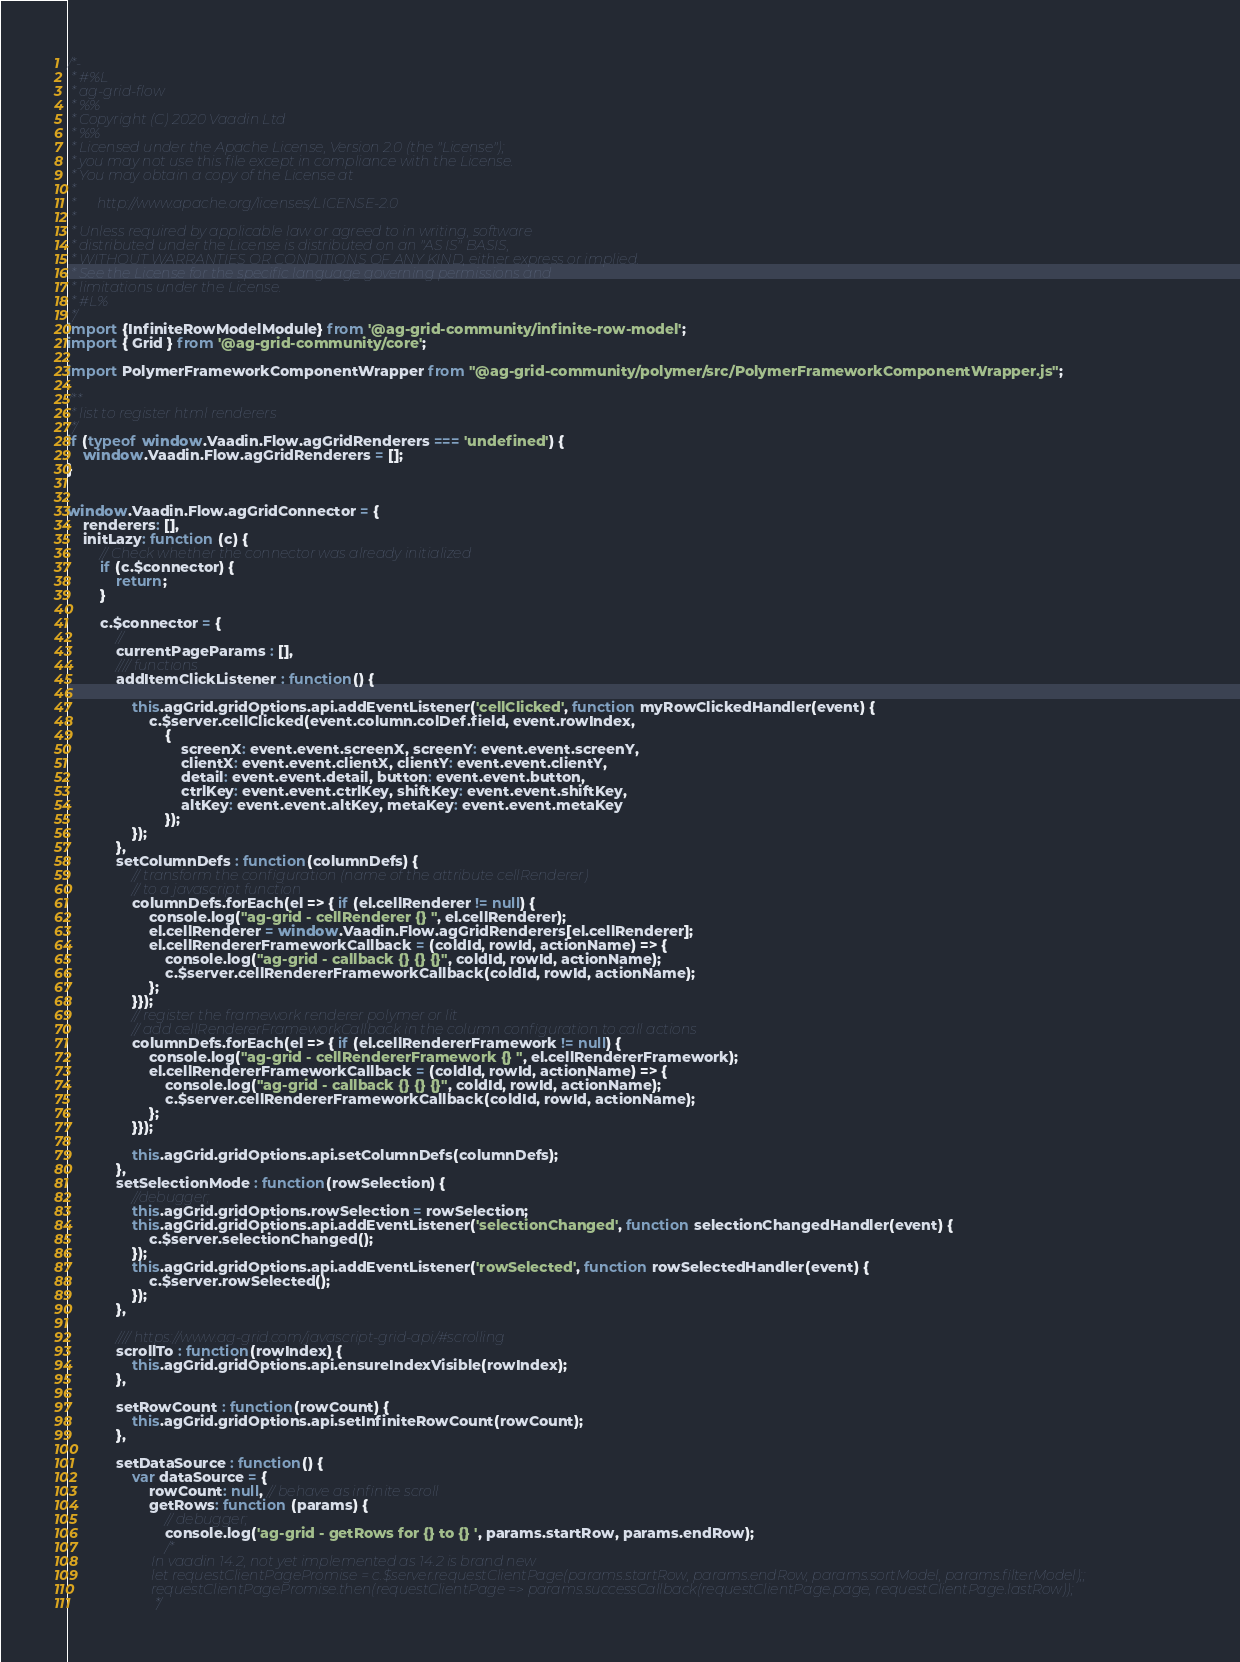<code> <loc_0><loc_0><loc_500><loc_500><_JavaScript_>/*-
 * #%L
 * ag-grid-flow
 * %%
 * Copyright (C) 2020 Vaadin Ltd
 * %%
 * Licensed under the Apache License, Version 2.0 (the "License");
 * you may not use this file except in compliance with the License.
 * You may obtain a copy of the License at
 * 
 *      http://www.apache.org/licenses/LICENSE-2.0
 * 
 * Unless required by applicable law or agreed to in writing, software
 * distributed under the License is distributed on an "AS IS" BASIS,
 * WITHOUT WARRANTIES OR CONDITIONS OF ANY KIND, either express or implied.
 * See the License for the specific language governing permissions and
 * limitations under the License.
 * #L%
 */
import {InfiniteRowModelModule} from '@ag-grid-community/infinite-row-model';
import { Grid } from '@ag-grid-community/core';

import PolymerFrameworkComponentWrapper from "@ag-grid-community/polymer/src/PolymerFrameworkComponentWrapper.js";

/**
 * list to register html renderers
 */
if (typeof window.Vaadin.Flow.agGridRenderers === 'undefined') {
    window.Vaadin.Flow.agGridRenderers = [];
}


window.Vaadin.Flow.agGridConnector = {
    renderers: [],
    initLazy: function (c) {
        // Check whether the connector was already initialized
        if (c.$connector) {
            return;
        }

        c.$connector = {
            //
            currentPageParams : [],
            //// functions
            addItemClickListener : function() {

                this.agGrid.gridOptions.api.addEventListener('cellClicked', function myRowClickedHandler(event) {
                    c.$server.cellClicked(event.column.colDef.field, event.rowIndex,
                        {
                            screenX: event.event.screenX, screenY: event.event.screenY,
                            clientX: event.event.clientX, clientY: event.event.clientY,
                            detail: event.event.detail, button: event.event.button,
                            ctrlKey: event.event.ctrlKey, shiftKey: event.event.shiftKey,
                            altKey: event.event.altKey, metaKey: event.event.metaKey
                        });
                });
            },
            setColumnDefs : function(columnDefs) {
                // transform the configuration (name of the attribute cellRenderer)
                // to a javascript function
                columnDefs.forEach(el => { if (el.cellRenderer != null) {
                    console.log("ag-grid - cellRenderer {} ", el.cellRenderer);
                    el.cellRenderer = window.Vaadin.Flow.agGridRenderers[el.cellRenderer];
                    el.cellRendererFrameworkCallback = (coldId, rowId, actionName) => {
                        console.log("ag-grid - callback {} {} {}", coldId, rowId, actionName);
                        c.$server.cellRendererFrameworkCallback(coldId, rowId, actionName);
                    };
                }});
                // register the framework renderer polymer or lit
                // add cellRendererFrameworkCallback in the column configuration to call actions
                columnDefs.forEach(el => { if (el.cellRendererFramework != null) {
                    console.log("ag-grid - cellRendererFramework {} ", el.cellRendererFramework);
                    el.cellRendererFrameworkCallback = (coldId, rowId, actionName) => {
                        console.log("ag-grid - callback {} {} {}", coldId, rowId, actionName);
                        c.$server.cellRendererFrameworkCallback(coldId, rowId, actionName);
                    };
                }});

                this.agGrid.gridOptions.api.setColumnDefs(columnDefs);
            },
            setSelectionMode : function(rowSelection) {
                //debugger;
                this.agGrid.gridOptions.rowSelection = rowSelection;
                this.agGrid.gridOptions.api.addEventListener('selectionChanged', function selectionChangedHandler(event) {
                    c.$server.selectionChanged();
                });
                this.agGrid.gridOptions.api.addEventListener('rowSelected', function rowSelectedHandler(event) {
                    c.$server.rowSelected();
                });
            },

            //// https://www.ag-grid.com/javascript-grid-api/#scrolling
            scrollTo : function(rowIndex) {
                this.agGrid.gridOptions.api.ensureIndexVisible(rowIndex);
            },

            setRowCount : function(rowCount) {
                this.agGrid.gridOptions.api.setInfiniteRowCount(rowCount);
            },

            setDataSource : function() {
                var dataSource = {
                    rowCount: null, // behave as infinite scroll
                    getRows: function (params) {
                        // debugger;
                        console.log('ag-grid - getRows for {} to {} ', params.startRow, params.endRow);
                        /*
                        In vaadin 14.2, not yet implemented as 14.2 is brand new
                        let requestClientPagePromise = c.$server.requestClientPage(params.startRow, params.endRow, params.sortModel, params.filterModel);;
                        requestClientPagePromise.then(requestClientPage => params.successCallback(requestClientPage.page, requestClientPage.lastRow));
                         */</code> 